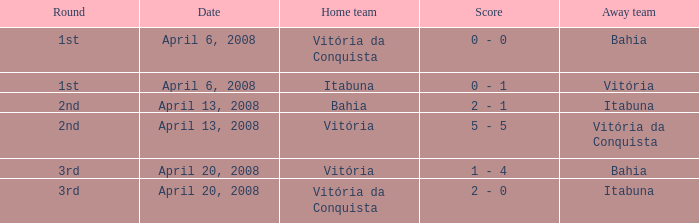Who was the home team on April 13, 2008 when Itabuna was the away team? Bahia. 